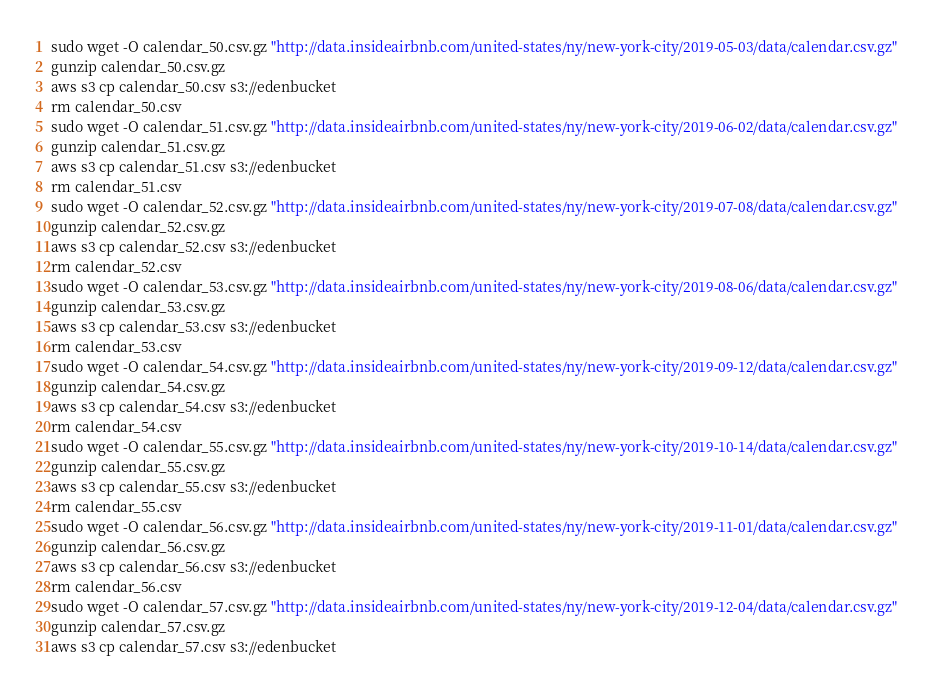<code> <loc_0><loc_0><loc_500><loc_500><_Bash_>sudo wget -O calendar_50.csv.gz "http://data.insideairbnb.com/united-states/ny/new-york-city/2019-05-03/data/calendar.csv.gz"
gunzip calendar_50.csv.gz
aws s3 cp calendar_50.csv s3://edenbucket
rm calendar_50.csv
sudo wget -O calendar_51.csv.gz "http://data.insideairbnb.com/united-states/ny/new-york-city/2019-06-02/data/calendar.csv.gz"
gunzip calendar_51.csv.gz
aws s3 cp calendar_51.csv s3://edenbucket
rm calendar_51.csv
sudo wget -O calendar_52.csv.gz "http://data.insideairbnb.com/united-states/ny/new-york-city/2019-07-08/data/calendar.csv.gz"
gunzip calendar_52.csv.gz
aws s3 cp calendar_52.csv s3://edenbucket
rm calendar_52.csv
sudo wget -O calendar_53.csv.gz "http://data.insideairbnb.com/united-states/ny/new-york-city/2019-08-06/data/calendar.csv.gz"
gunzip calendar_53.csv.gz
aws s3 cp calendar_53.csv s3://edenbucket
rm calendar_53.csv
sudo wget -O calendar_54.csv.gz "http://data.insideairbnb.com/united-states/ny/new-york-city/2019-09-12/data/calendar.csv.gz"
gunzip calendar_54.csv.gz
aws s3 cp calendar_54.csv s3://edenbucket
rm calendar_54.csv
sudo wget -O calendar_55.csv.gz "http://data.insideairbnb.com/united-states/ny/new-york-city/2019-10-14/data/calendar.csv.gz"
gunzip calendar_55.csv.gz
aws s3 cp calendar_55.csv s3://edenbucket
rm calendar_55.csv
sudo wget -O calendar_56.csv.gz "http://data.insideairbnb.com/united-states/ny/new-york-city/2019-11-01/data/calendar.csv.gz"
gunzip calendar_56.csv.gz
aws s3 cp calendar_56.csv s3://edenbucket
rm calendar_56.csv
sudo wget -O calendar_57.csv.gz "http://data.insideairbnb.com/united-states/ny/new-york-city/2019-12-04/data/calendar.csv.gz"
gunzip calendar_57.csv.gz
aws s3 cp calendar_57.csv s3://edenbucket</code> 